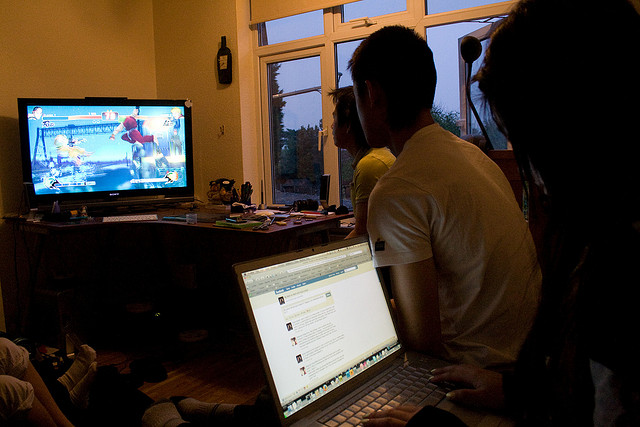<image>What game system is the man playing? I don't know what game system the man is playing. It can be a computer, xbox, pc, wii, ps3 or nintendo. What game system is the man playing? I am not sure what game system the man is playing. It can be seen that he is playing on a computer, Xbox, PC, Wii, PS3, Nintendo or it can also be some other unknown system. 